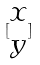Convert formula to latex. <formula><loc_0><loc_0><loc_500><loc_500>[ \begin{matrix} x \\ y \end{matrix} ]</formula> 